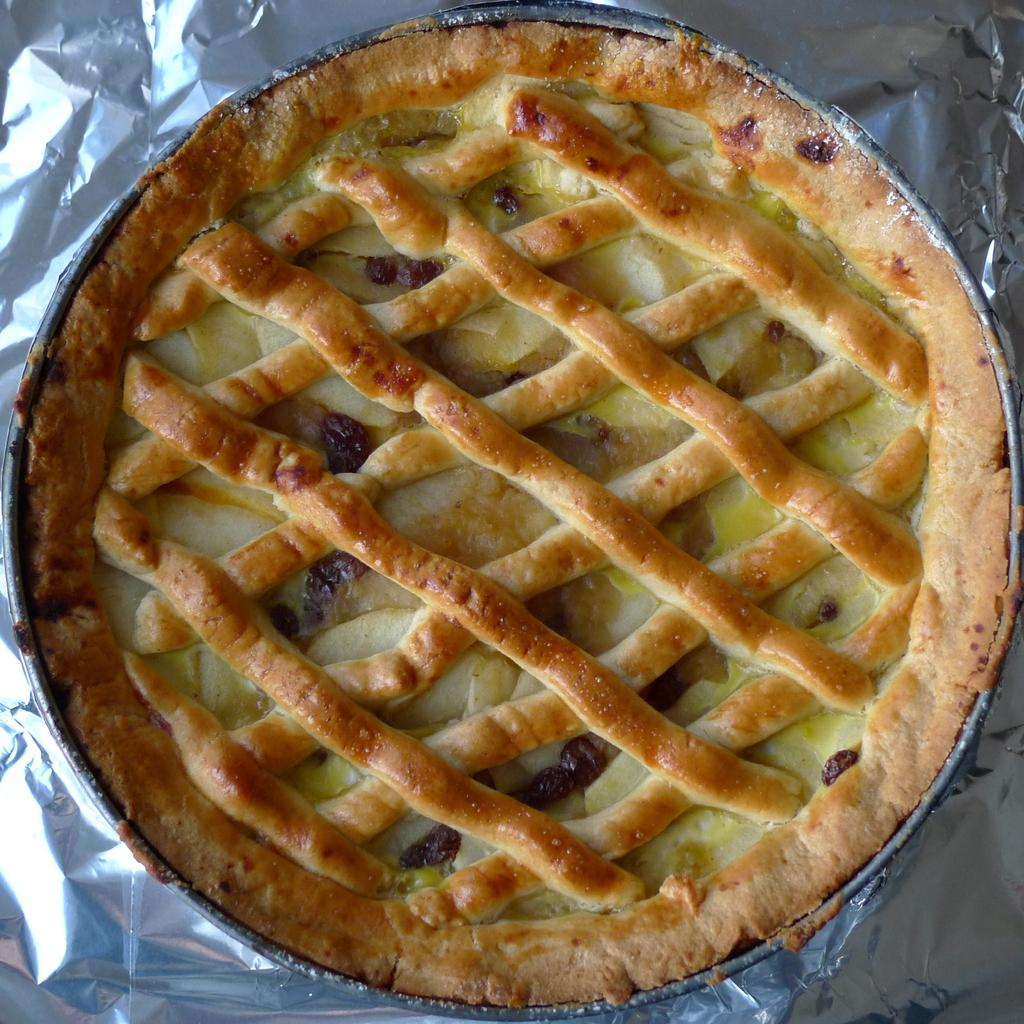What is the main food item visible in the image? There is a pie on a plate in the image. What is used to cover the surface beneath the plate? There is an aluminium foil under the plate in the image. What type of zinc object can be seen interacting with the pie in the image? There is no zinc object present in the image, and therefore no such interaction can be observed. 